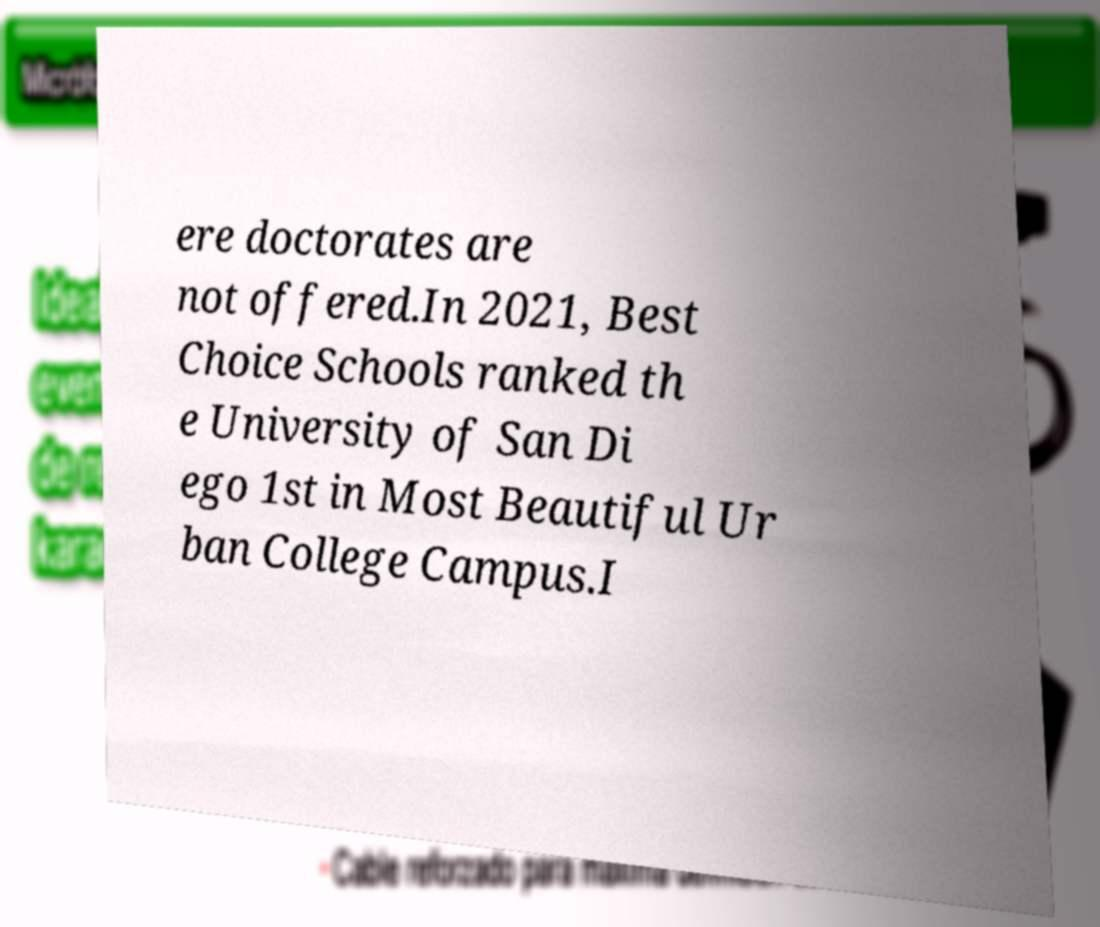There's text embedded in this image that I need extracted. Can you transcribe it verbatim? ere doctorates are not offered.In 2021, Best Choice Schools ranked th e University of San Di ego 1st in Most Beautiful Ur ban College Campus.I 